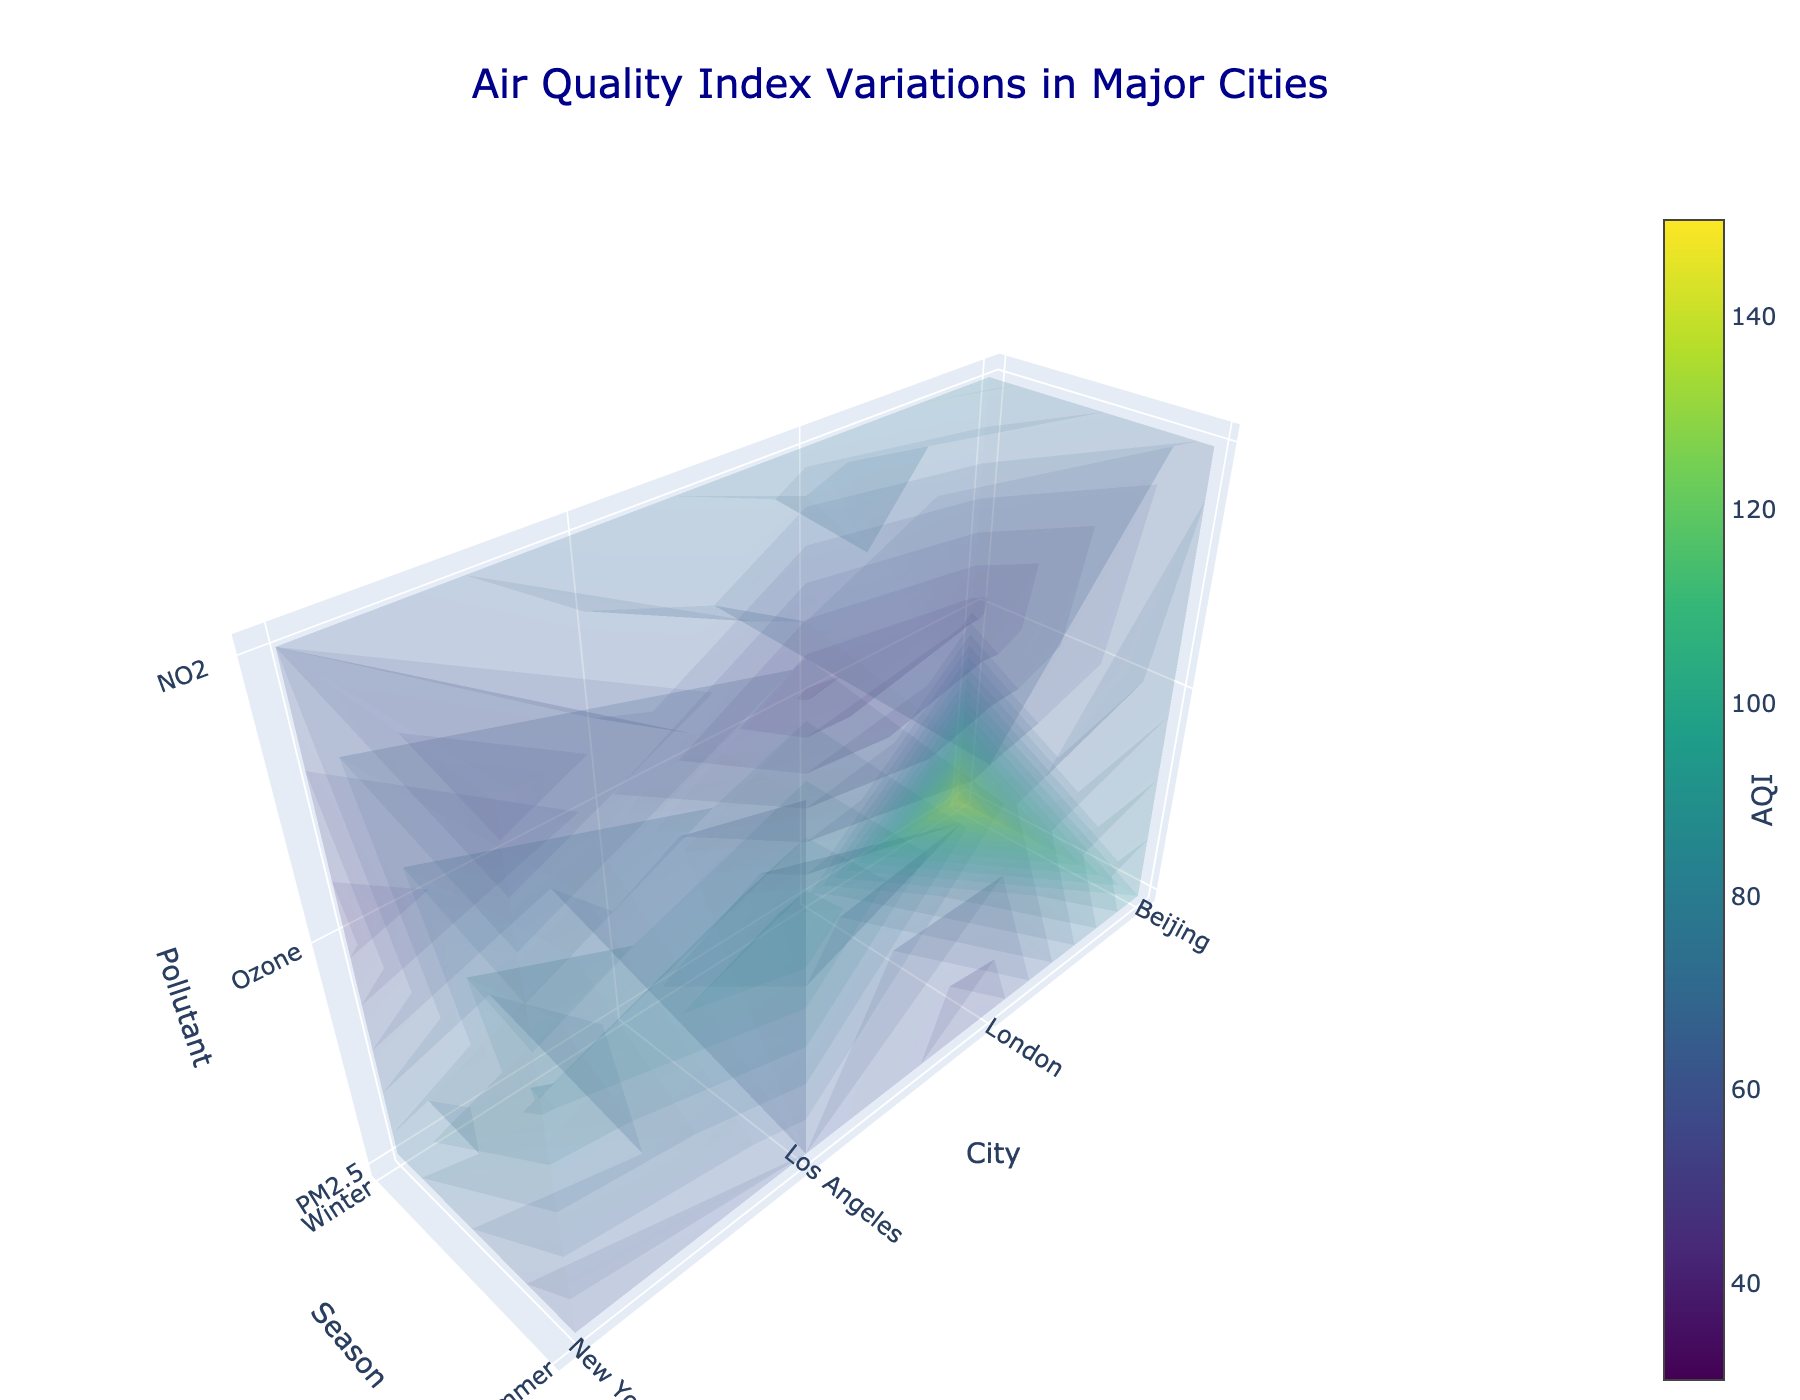Which city's AQI for PM2.5 is highest in Winter? From the plot, observe the z-axis at PM2.5 level and compare the AQI values for Winter (y-axis) in each city (x-axis). Beijing has the highest AQI value for PM2.5 in Winter.
Answer: Beijing What is the average AQI for Ozone in the Summer season across all cities? Look at the Summer time on the y-axis and the Ozone pollutant on the z-axis, then sum up the AQI values for all cities and divide by the total number of cities. (85+95+70+65)/4 = 78.75
Answer: 78.75 Which city shows the most significant difference in AQI for PM2.5 between Winter and Summer? Compare the AQI values for PM2.5 across both seasons (Winter and Summer) for each city and find the absolute differences: New York (75-55), Los Angeles (65-60), Beijing (150-90), and London (70-50). The largest difference is for Beijing.
Answer: Beijing How does the AQI for NO2 compare between New York and London in Winter? On the winter tick (y-axis) at the NO2 level (z-axis), compare New York's value with London's value. New York's AQI is 60 and London's AQI is 75, so London has a higher AQI for NO2.
Answer: London For which pollutant and season is Los Angeles's AQI the lowest? Check the values for Los Angeles across all pollutants and both seasons, then identify the minimum value. The lowest is the AQI for PM2.5 in Summer with a value of 60.
Answer: PM2.5 in Summer Which season generally has higher Ozone levels across the cities? Compare the AQI for Ozone in Winter and Summer across all cities by looking at the Ozone level on the z-axis for both y-axis ticks (Winter and Summer). The AQI for Ozone is generally higher in Summer across all cities.
Answer: Summer What's the total AQI of PM2.5 for Beijing in both seasons combined? Sum the AQI values for PM2.5 in Winter and Summer for Beijing: 150 (Winter) + 90 (Summer) = 240.
Answer: 240 In which city is the AQI for NO2 in Summer the lowest? Look at the NO2 level on the z-axis during Summer (y-axis), and compare AQI values across all cities. The lowest value is for New York with an AQI of 50.
Answer: New York 